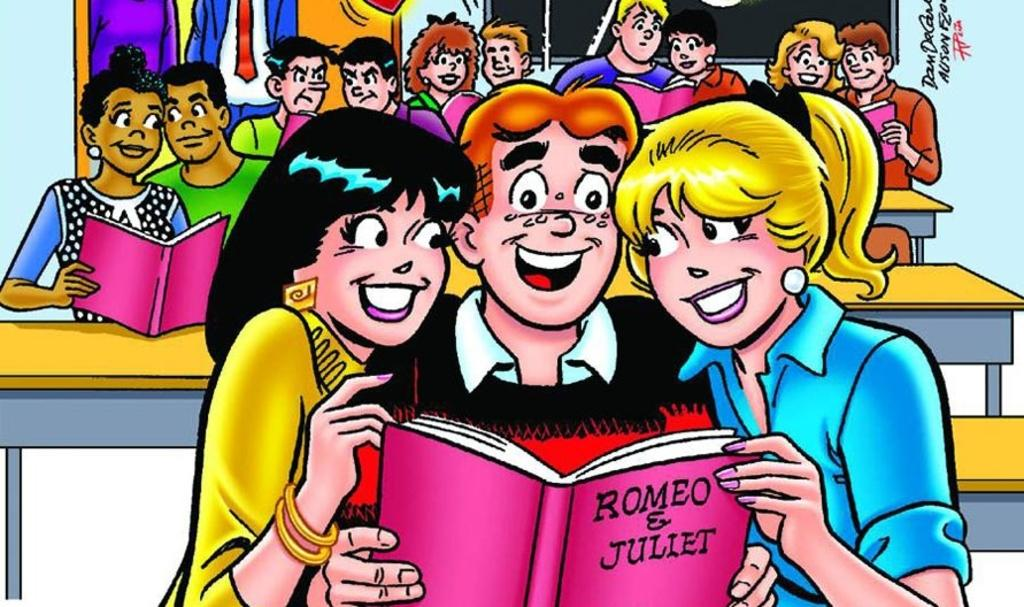How many people are present in the image? There are many people in the image. What can be seen in the image besides the people? There are tables in the image. What are some people doing in the image? Some people are holding books in the image. What type of vessel is being used by the people in the image? There is no vessel present in the image; the people are holding books, not a vessel. 